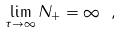Convert formula to latex. <formula><loc_0><loc_0><loc_500><loc_500>\lim _ { \tau \rightarrow \infty } N _ { + } = \infty \ ,</formula> 